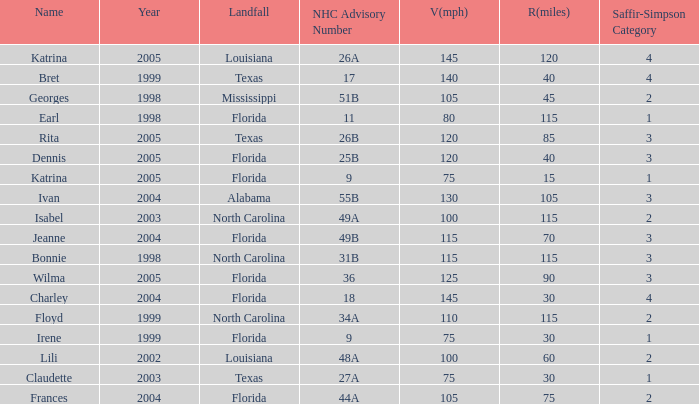What was the lowest V(mph) for a Saffir-Simpson of 4 in 2005? 145.0. 